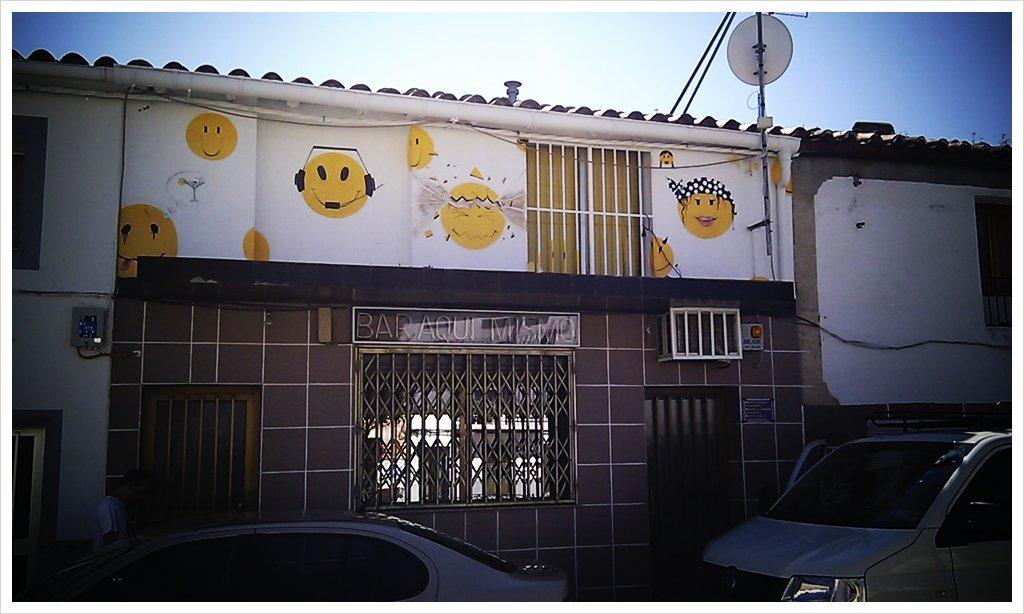What type of structure can be seen in the background of the image? There is a house in the background of the image. What feature is present in the foreground of the image? There is a door in the image. What is visible at the top of the image? The sky is visible at the top of the image. What type of vehicles can be seen at the bottom of the image? Cars are present at the bottom of the image. Are there any fangs visible on the door in the image? There are no fangs present in the image; the door is a regular door without any fangs. Can you see any cactus plants in the image? There are no cactus plants visible in the image. 